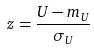<formula> <loc_0><loc_0><loc_500><loc_500>z = \frac { U - m _ { U } } { \sigma _ { U } }</formula> 